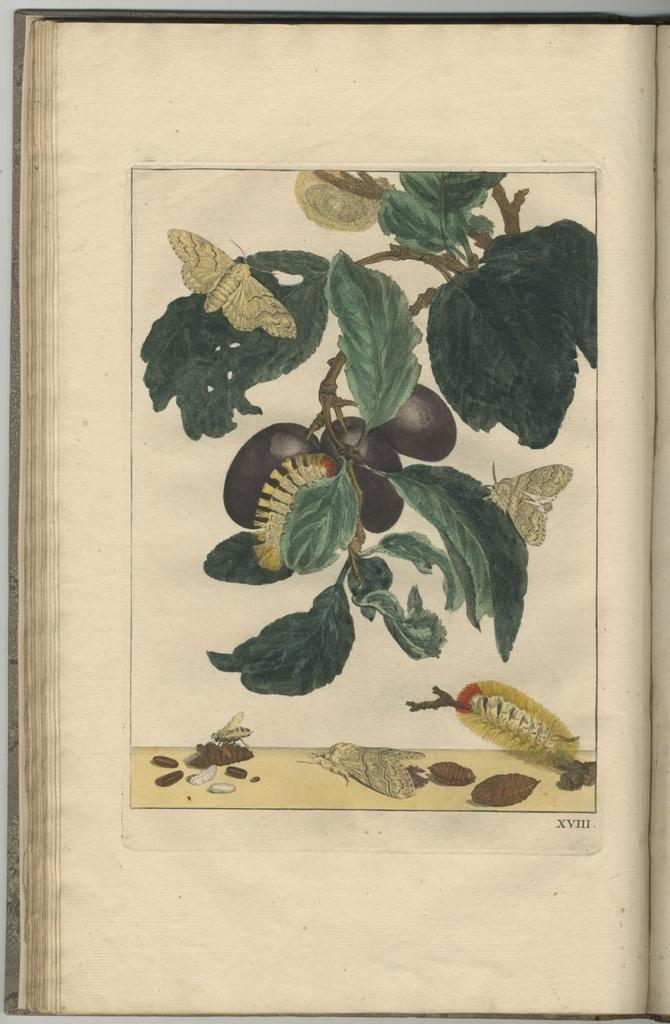What is the main subject of the image? The main subject of the image is an open book. What can be found within the pages of the book? The book contains a sketch of a plant with leaves and fruits. Are there any other living organisms depicted in the sketch? Yes, there is an insect depicted in the sketch. Can you describe any other elements in the sketch? Unfortunately, the facts provided do not specify any other elements in the sketch. What type of club can be seen in the image? There is no club present in the image; it features an open book with a sketch of a plant and an insect. Is there a crib visible in the image? No, there is no crib present in the image. 